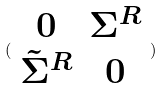<formula> <loc_0><loc_0><loc_500><loc_500>( \begin{array} { c c } 0 & \Sigma ^ { R } \\ \tilde { \Sigma } ^ { R } & 0 \end{array} )</formula> 